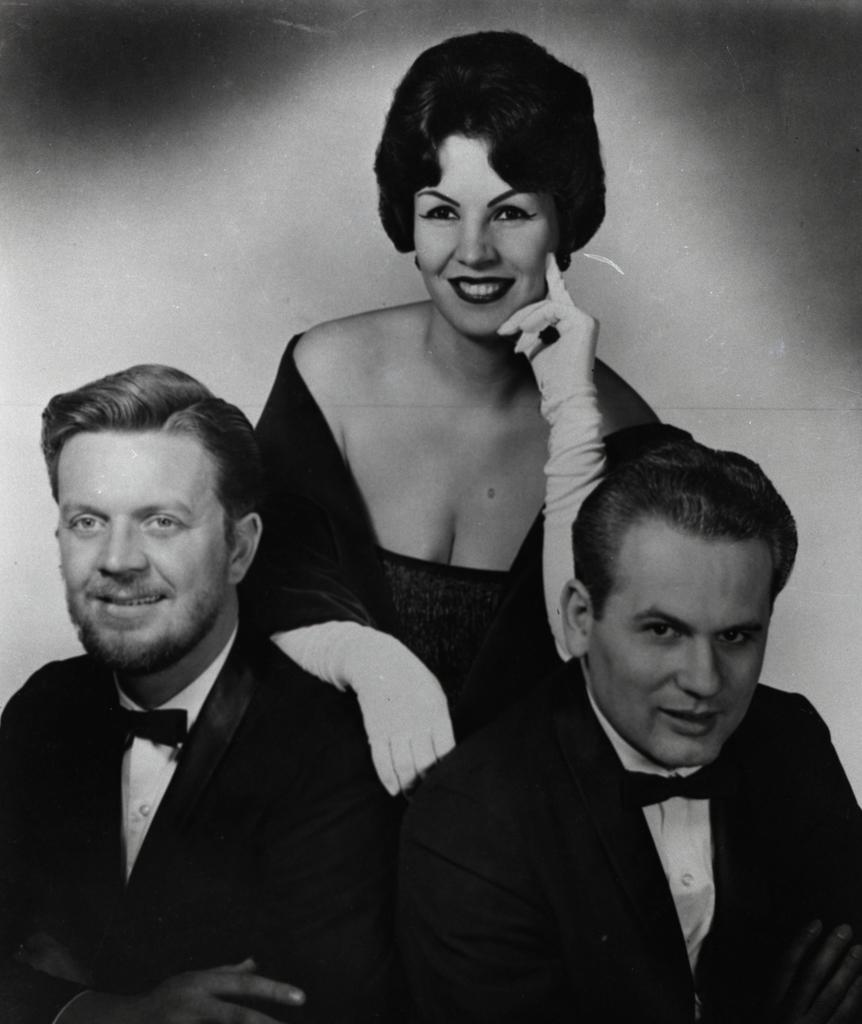What is the color scheme of the image? The image is black and white. How many people are present in the image? There are three individuals in the image: two men and one woman. What is the facial expression of the people in the image? All three individuals are smiling. What month is depicted in the image? The image does not depict a month; it is a black and white photograph of three people smiling. How are the two men and the woman connected in the image? The image does not provide any information about how the two men and the woman are connected; it simply shows them smiling together. 